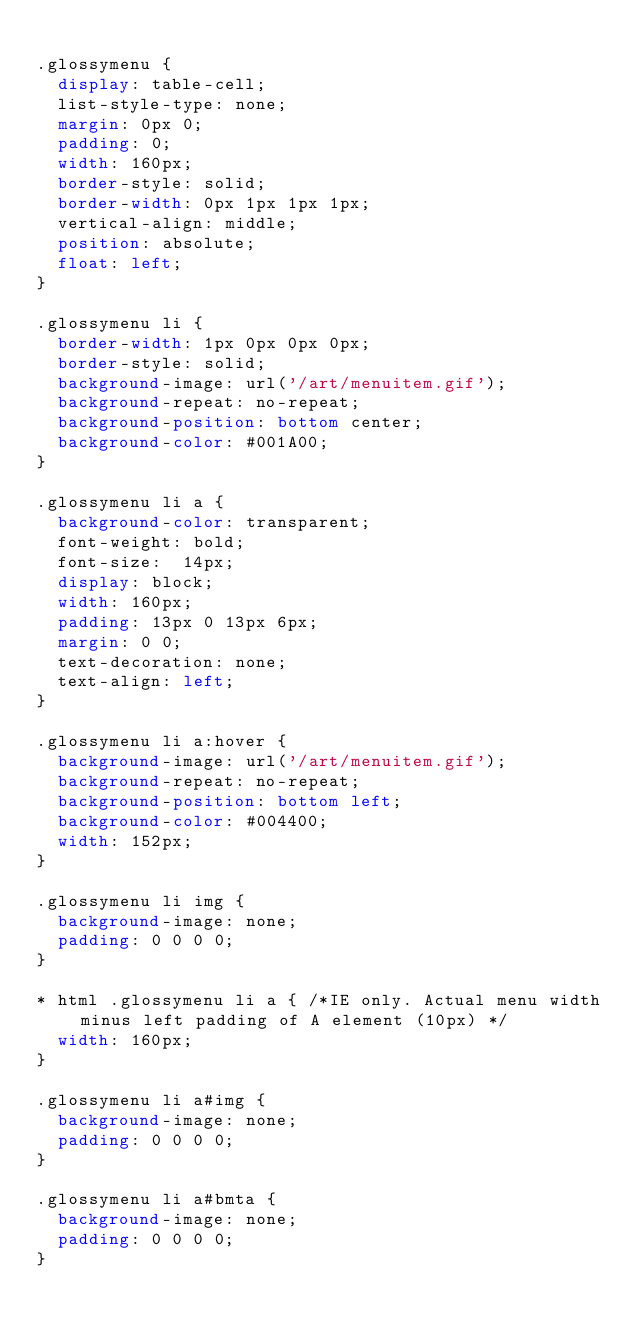<code> <loc_0><loc_0><loc_500><loc_500><_CSS_>
.glossymenu {
  display: table-cell;
  list-style-type: none;
  margin: 0px 0;
  padding: 0;
  width: 160px;
  border-style: solid;
  border-width: 0px 1px 1px 1px;
  vertical-align: middle;
  position: absolute;
  float: left;
}

.glossymenu li {
  border-width: 1px 0px 0px 0px;
  border-style: solid;
  background-image: url('/art/menuitem.gif');
  background-repeat: no-repeat;
  background-position: bottom center;
  background-color: #001A00;
}

.glossymenu li a {
  background-color: transparent;
  font-weight: bold;
  font-size:  14px;
  display: block;
  width: 160px;
  padding: 13px 0 13px 6px;
  margin: 0 0;
  text-decoration: none;
  text-align: left;
}

.glossymenu li a:hover {
  background-image: url('/art/menuitem.gif');
  background-repeat: no-repeat;
  background-position: bottom left;
  background-color: #004400;
  width: 152px;
}

.glossymenu li img {
  background-image: none;
  padding: 0 0 0 0;
}

* html .glossymenu li a { /*IE only. Actual menu width minus left padding of A element (10px) */
  width: 160px;
}

.glossymenu li a#img {
  background-image: none;
  padding: 0 0 0 0;
}

.glossymenu li a#bmta {
  background-image: none;
  padding: 0 0 0 0;
}

</code> 